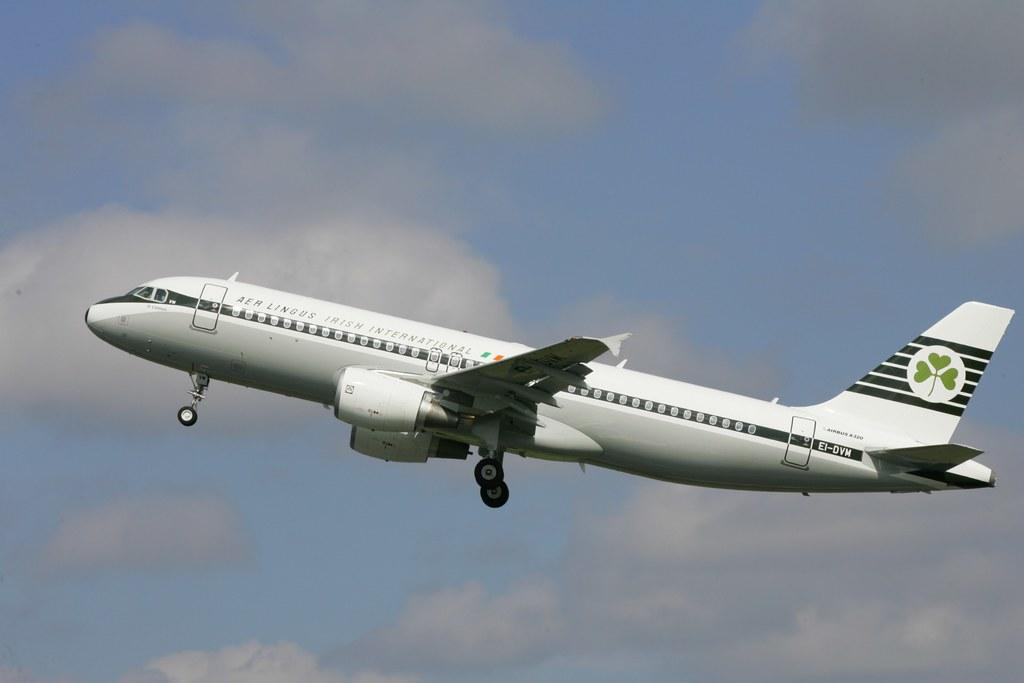What is the main subject of the image? The main subject of the image is an airplane. What is the color of the airplane? The airplane is white in color. What can be seen in the background of the image? There are clouds in the sky in the background of the image. What type of stew is being served on the airplane in the image? There is no stew present in the image, as it only features an airplane and clouds in the sky. Can you see any teeth or toothbrushes in the image? There are no teeth or toothbrushes visible in the image. 